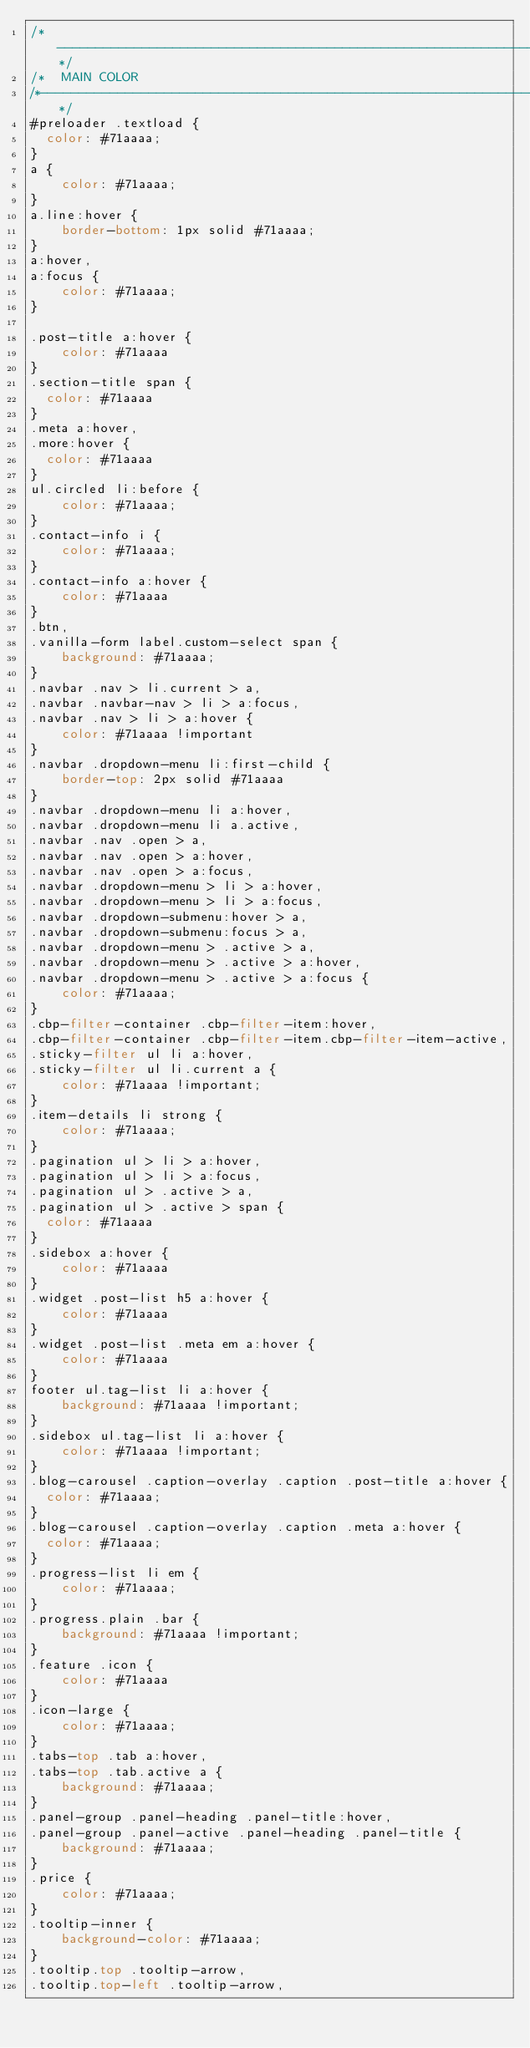<code> <loc_0><loc_0><loc_500><loc_500><_CSS_>/*-----------------------------------------------------------------------------------*/
/*	MAIN COLOR
/*-----------------------------------------------------------------------------------*/
#preloader .textload {
	color: #71aaaa;
}
a {
    color: #71aaaa;
}
a.line:hover {
    border-bottom: 1px solid #71aaaa;
}
a:hover,
a:focus {
    color: #71aaaa;
}

.post-title a:hover {
    color: #71aaaa
}
.section-title span {
	color: #71aaaa
}
.meta a:hover,
.more:hover {
	color: #71aaaa
}
ul.circled li:before {
    color: #71aaaa;
}
.contact-info i {
    color: #71aaaa;
}
.contact-info a:hover {
    color: #71aaaa
}
.btn,
.vanilla-form label.custom-select span {
    background: #71aaaa;
}
.navbar .nav > li.current > a,
.navbar .navbar-nav > li > a:focus,
.navbar .nav > li > a:hover {
    color: #71aaaa !important 
}
.navbar .dropdown-menu li:first-child {
    border-top: 2px solid #71aaaa
}
.navbar .dropdown-menu li a:hover,
.navbar .dropdown-menu li a.active,
.navbar .nav .open > a,
.navbar .nav .open > a:hover,
.navbar .nav .open > a:focus,
.navbar .dropdown-menu > li > a:hover,
.navbar .dropdown-menu > li > a:focus,
.navbar .dropdown-submenu:hover > a,
.navbar .dropdown-submenu:focus > a,
.navbar .dropdown-menu > .active > a,
.navbar .dropdown-menu > .active > a:hover,
.navbar .dropdown-menu > .active > a:focus {
    color: #71aaaa;
}
.cbp-filter-container .cbp-filter-item:hover,
.cbp-filter-container .cbp-filter-item.cbp-filter-item-active,
.sticky-filter ul li a:hover,
.sticky-filter ul li.current a {
    color: #71aaaa !important;
}
.item-details li strong {
    color: #71aaaa;
}
.pagination ul > li > a:hover,
.pagination ul > li > a:focus,
.pagination ul > .active > a,
.pagination ul > .active > span {
	color: #71aaaa
}
.sidebox a:hover {
    color: #71aaaa
}
.widget .post-list h5 a:hover {
    color: #71aaaa
}
.widget .post-list .meta em a:hover {
    color: #71aaaa
}
footer ul.tag-list li a:hover {
    background: #71aaaa !important;
}
.sidebox ul.tag-list li a:hover {
    color: #71aaaa !important;
}
.blog-carousel .caption-overlay .caption .post-title a:hover {
	color: #71aaaa;
}
.blog-carousel .caption-overlay .caption .meta a:hover {
	color: #71aaaa;
}
.progress-list li em {
    color: #71aaaa;
}
.progress.plain .bar {
    background: #71aaaa !important;
}
.feature .icon {
    color: #71aaaa
}
.icon-large {
    color: #71aaaa;
}
.tabs-top .tab a:hover,
.tabs-top .tab.active a {
    background: #71aaaa;
}
.panel-group .panel-heading .panel-title:hover,
.panel-group .panel-active .panel-heading .panel-title {
    background: #71aaaa;
}
.price {
    color: #71aaaa;
}
.tooltip-inner {
    background-color: #71aaaa;
}
.tooltip.top .tooltip-arrow,
.tooltip.top-left .tooltip-arrow,</code> 